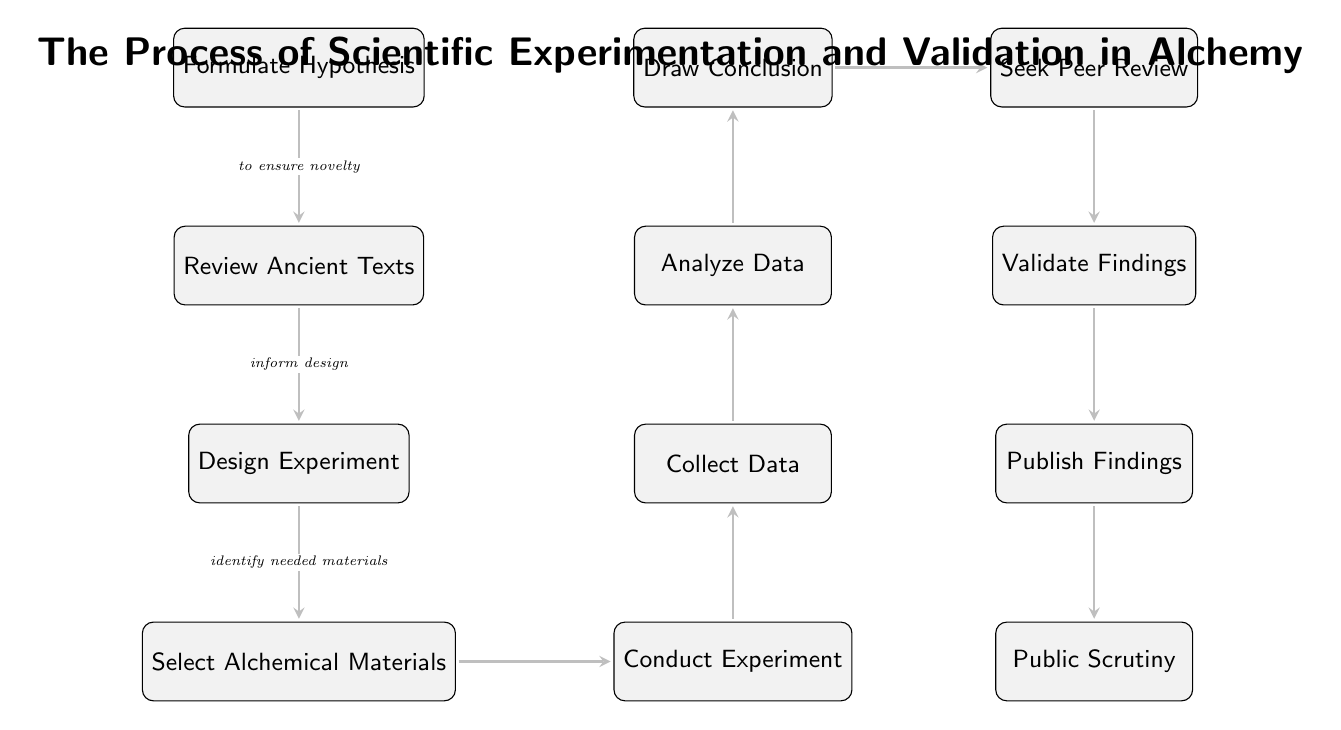What is the final step in the process? The final step in the process is indicated at the bottom of the diagram, labeled as "Public Scrutiny."
Answer: Public Scrutiny What comes before "Seek Peer Review"? The node that comes immediately before "Seek Peer Review" is "Draw Conclusion," as seen in the diagram's flow.
Answer: Draw Conclusion How many nodes are in the diagram? By counting each box representing a step in the process, there are a total of 11 nodes displayed.
Answer: 11 What is the purpose of the "Review Ancient Texts" node? The label on the arrow leading to this node states its purpose is "to ensure novelty," indicating that this step is meant to confirm that the hypothesis is original.
Answer: to ensure novelty Which step follows "Validate Findings"? "Publish Findings" directly follows "Validate Findings" as shown by the downward connection in the diagram.
Answer: Publish Findings What step requires analyzing collected data? The step labeled "Analyze Data" is responsible for analyzing the data collected in the previous step, as indicated by the directional flow between these nodes.
Answer: Analyze Data What step is linked to both "Conduct Experiment" and "Collect Data"? The "Conduct Experiment" node is directly connected to the "Collect Data" node, highlighting that data collection happens post-experimentation.
Answer: Collect Data How is the "Formulate Hypothesis" step related to the "Review Ancient Texts"? The arrow indicates that the relationship is such that the formulation of a hypothesis leads to a review of ancient texts, which is stated to "ensure novelty."
Answer: to ensure novelty What is the immediate outcome after "Analyze Data"? The immediate outcome is "Draw Conclusion," which comes right after analyzing the data in the sequence of steps.
Answer: Draw Conclusion What does the "Seek Peer Review" step aim to achieve? This step is crucial for validating the work through external scrutiny, indicated by the flow leading towards "Validate Findings."
Answer: Validate Findings 